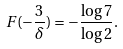<formula> <loc_0><loc_0><loc_500><loc_500>F ( - \frac { 3 } { \delta } ) = - \frac { \log 7 } { \log 2 } .</formula> 